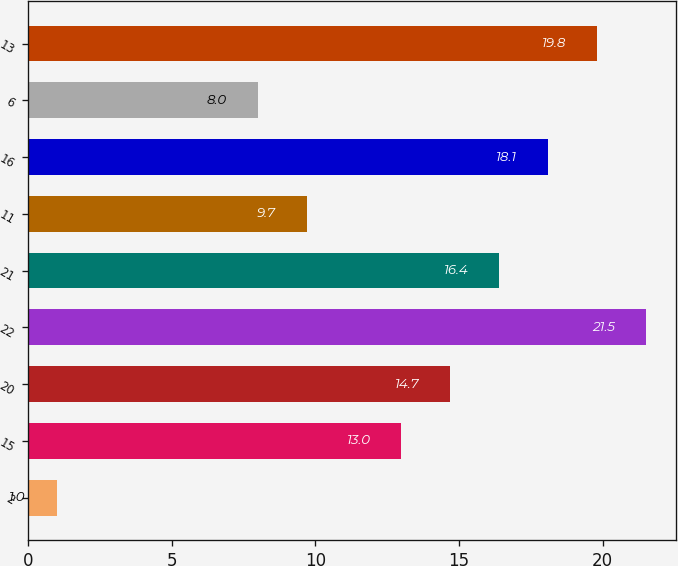Convert chart to OTSL. <chart><loc_0><loc_0><loc_500><loc_500><bar_chart><fcel>2<fcel>15<fcel>20<fcel>22<fcel>21<fcel>11<fcel>16<fcel>6<fcel>13<nl><fcel>1<fcel>13<fcel>14.7<fcel>21.5<fcel>16.4<fcel>9.7<fcel>18.1<fcel>8<fcel>19.8<nl></chart> 